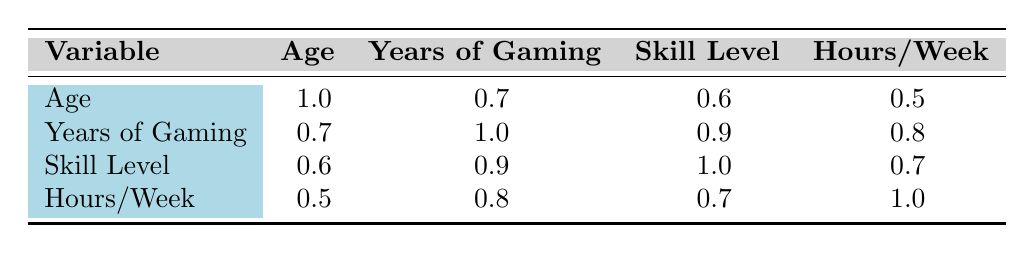What is the correlation value between Age and Years of Gaming? The table lists the correlation values where "Age" is in the first row and "Years of Gaming" is in the second column. The value at the intersection of these two is 0.7.
Answer: 0.7 Is there a strong correlation between Skill Level and Hours Played per Week? The table shows that the correlation between "Skill Level" and "Hours/Week" is 0.7, which indicates a moderate to strong positive correlation.
Answer: Yes What is the average correlation value between Years of Gaming and other variables? We take the correlation values for "Years of Gaming": with Age (0.7), Skill Level (0.9), and Hours/Week (0.8). Summing these gives 0.7 + 0.9 + 0.8 = 2.4. There are three correlations, so the average is 2.4 / 3 = 0.8.
Answer: 0.8 Is the correlation between Age and Skill Level higher than the correlation between Years of Gaming and Hours Played per Week? The correlation between Age and Skill Level is 0.6, while Years of Gaming and Hours/Week has a correlation of 0.8. Since 0.6 is less than 0.8, this statement is false.
Answer: No What do the correlations suggest about the relationship between gaming experience and skill level? The table shows a strong correlation of 0.9 between "Years of Gaming" and "Skill Level." This suggests that as years of gaming experience increase, skill level tends to increase as well.
Answer: Positive relationship 